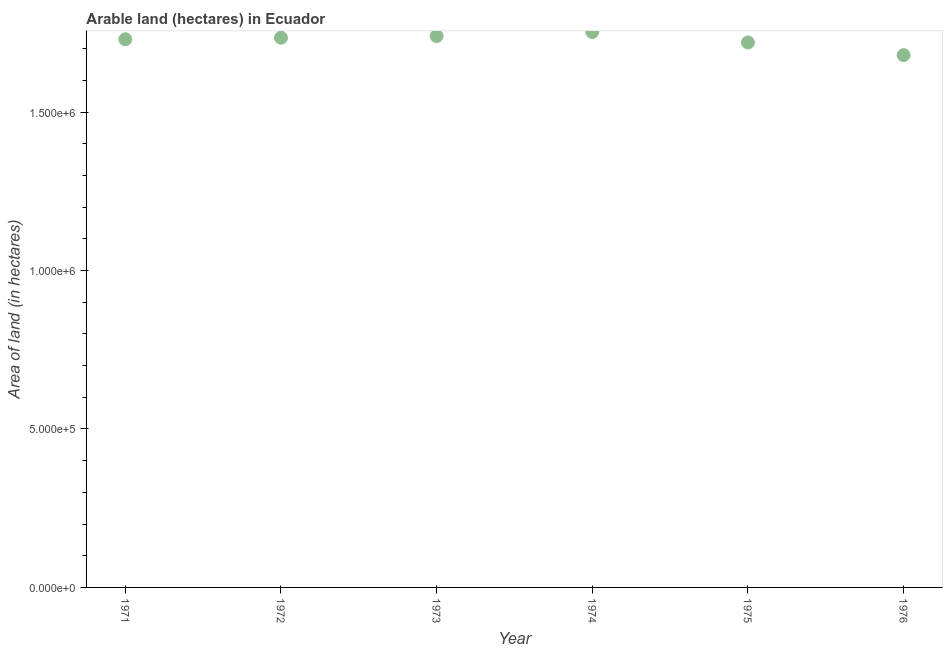What is the area of land in 1976?
Your answer should be very brief. 1.68e+06. Across all years, what is the maximum area of land?
Ensure brevity in your answer.  1.75e+06. Across all years, what is the minimum area of land?
Make the answer very short. 1.68e+06. In which year was the area of land maximum?
Your response must be concise. 1974. In which year was the area of land minimum?
Your answer should be very brief. 1976. What is the sum of the area of land?
Your answer should be very brief. 1.04e+07. What is the difference between the area of land in 1971 and 1973?
Your response must be concise. -10000. What is the average area of land per year?
Offer a terse response. 1.73e+06. What is the median area of land?
Your response must be concise. 1.73e+06. In how many years, is the area of land greater than 400000 hectares?
Offer a very short reply. 6. What is the ratio of the area of land in 1974 to that in 1975?
Your answer should be compact. 1.02. Is the area of land in 1974 less than that in 1975?
Provide a short and direct response. No. Is the difference between the area of land in 1974 and 1975 greater than the difference between any two years?
Provide a succinct answer. No. What is the difference between the highest and the second highest area of land?
Provide a succinct answer. 1.30e+04. What is the difference between the highest and the lowest area of land?
Make the answer very short. 7.30e+04. In how many years, is the area of land greater than the average area of land taken over all years?
Make the answer very short. 4. How many dotlines are there?
Make the answer very short. 1. What is the difference between two consecutive major ticks on the Y-axis?
Give a very brief answer. 5.00e+05. Are the values on the major ticks of Y-axis written in scientific E-notation?
Provide a succinct answer. Yes. What is the title of the graph?
Your response must be concise. Arable land (hectares) in Ecuador. What is the label or title of the X-axis?
Your answer should be compact. Year. What is the label or title of the Y-axis?
Offer a terse response. Area of land (in hectares). What is the Area of land (in hectares) in 1971?
Offer a very short reply. 1.73e+06. What is the Area of land (in hectares) in 1972?
Your answer should be compact. 1.74e+06. What is the Area of land (in hectares) in 1973?
Offer a terse response. 1.74e+06. What is the Area of land (in hectares) in 1974?
Your answer should be compact. 1.75e+06. What is the Area of land (in hectares) in 1975?
Your answer should be compact. 1.72e+06. What is the Area of land (in hectares) in 1976?
Make the answer very short. 1.68e+06. What is the difference between the Area of land (in hectares) in 1971 and 1972?
Ensure brevity in your answer.  -5000. What is the difference between the Area of land (in hectares) in 1971 and 1973?
Offer a terse response. -10000. What is the difference between the Area of land (in hectares) in 1971 and 1974?
Ensure brevity in your answer.  -2.30e+04. What is the difference between the Area of land (in hectares) in 1971 and 1976?
Keep it short and to the point. 5.00e+04. What is the difference between the Area of land (in hectares) in 1972 and 1973?
Offer a terse response. -5000. What is the difference between the Area of land (in hectares) in 1972 and 1974?
Your answer should be compact. -1.80e+04. What is the difference between the Area of land (in hectares) in 1972 and 1975?
Your answer should be very brief. 1.50e+04. What is the difference between the Area of land (in hectares) in 1972 and 1976?
Make the answer very short. 5.50e+04. What is the difference between the Area of land (in hectares) in 1973 and 1974?
Your response must be concise. -1.30e+04. What is the difference between the Area of land (in hectares) in 1973 and 1976?
Give a very brief answer. 6.00e+04. What is the difference between the Area of land (in hectares) in 1974 and 1975?
Provide a succinct answer. 3.30e+04. What is the difference between the Area of land (in hectares) in 1974 and 1976?
Provide a short and direct response. 7.30e+04. What is the difference between the Area of land (in hectares) in 1975 and 1976?
Ensure brevity in your answer.  4.00e+04. What is the ratio of the Area of land (in hectares) in 1971 to that in 1972?
Offer a very short reply. 1. What is the ratio of the Area of land (in hectares) in 1971 to that in 1973?
Provide a succinct answer. 0.99. What is the ratio of the Area of land (in hectares) in 1971 to that in 1974?
Your answer should be very brief. 0.99. What is the ratio of the Area of land (in hectares) in 1971 to that in 1975?
Offer a very short reply. 1.01. What is the ratio of the Area of land (in hectares) in 1971 to that in 1976?
Provide a succinct answer. 1.03. What is the ratio of the Area of land (in hectares) in 1972 to that in 1974?
Offer a terse response. 0.99. What is the ratio of the Area of land (in hectares) in 1972 to that in 1975?
Your answer should be compact. 1.01. What is the ratio of the Area of land (in hectares) in 1972 to that in 1976?
Give a very brief answer. 1.03. What is the ratio of the Area of land (in hectares) in 1973 to that in 1974?
Provide a succinct answer. 0.99. What is the ratio of the Area of land (in hectares) in 1973 to that in 1975?
Offer a very short reply. 1.01. What is the ratio of the Area of land (in hectares) in 1973 to that in 1976?
Keep it short and to the point. 1.04. What is the ratio of the Area of land (in hectares) in 1974 to that in 1976?
Your answer should be very brief. 1.04. What is the ratio of the Area of land (in hectares) in 1975 to that in 1976?
Offer a very short reply. 1.02. 